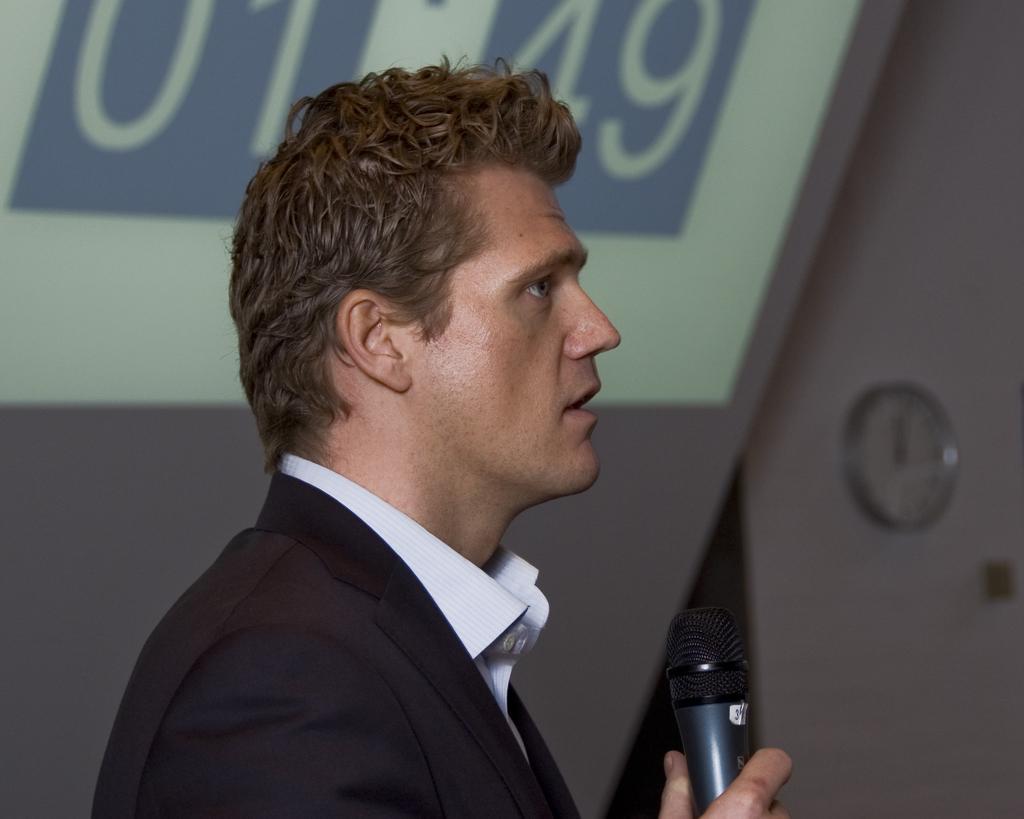Could you give a brief overview of what you see in this image? In the image we can see a man wearing black color blazer. He is holding a microphone in his hand. There is a clock stick to the wall. 